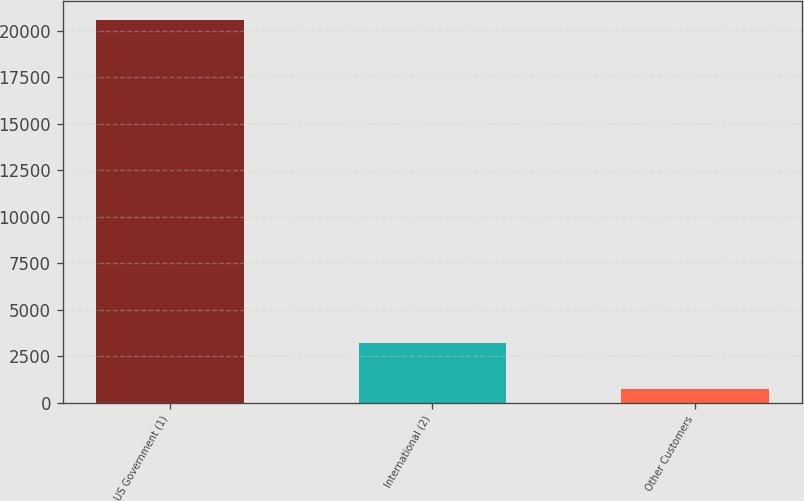<chart> <loc_0><loc_0><loc_500><loc_500><bar_chart><fcel>US Government (1)<fcel>International (2)<fcel>Other Customers<nl><fcel>20573<fcel>3205<fcel>730<nl></chart> 